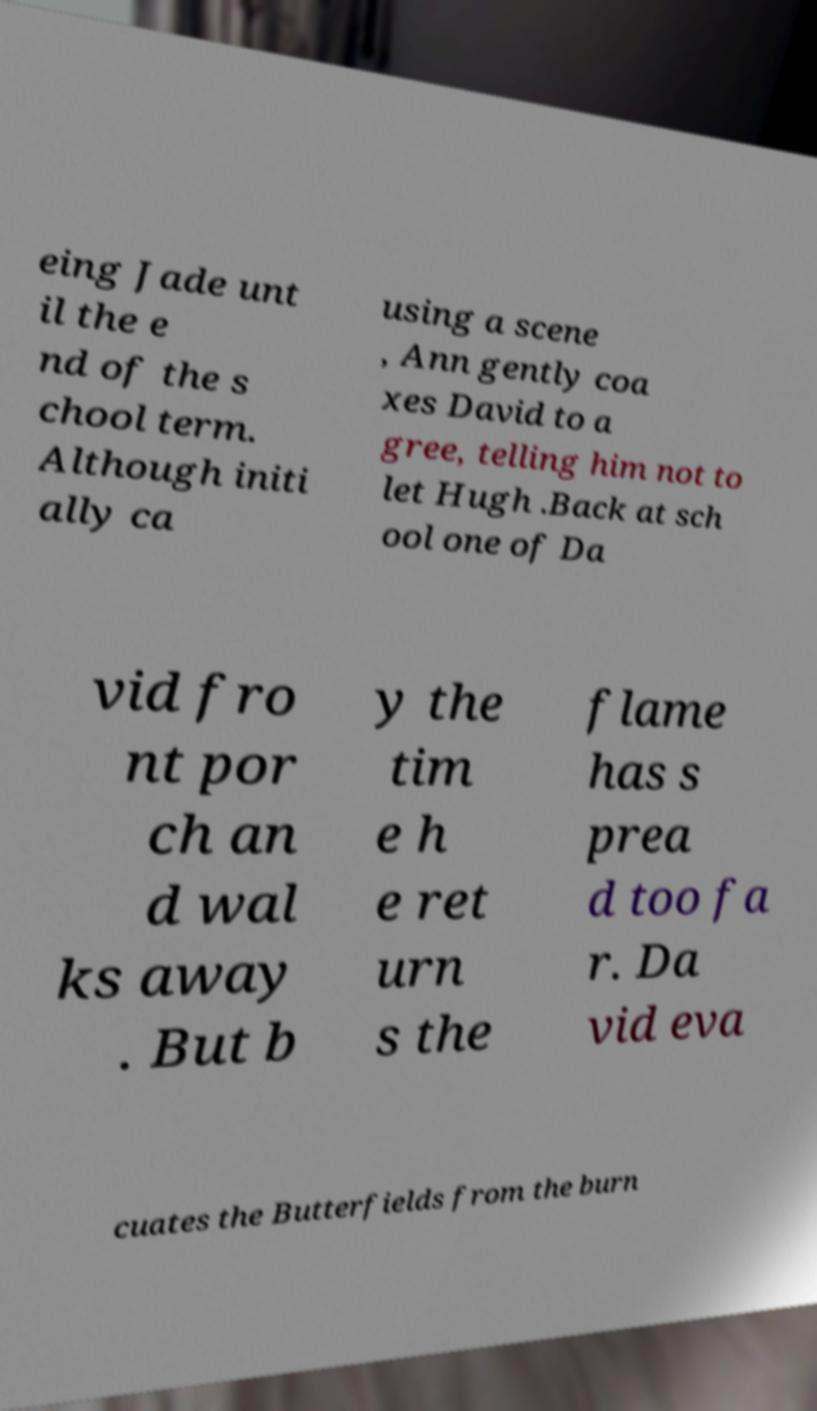Could you extract and type out the text from this image? eing Jade unt il the e nd of the s chool term. Although initi ally ca using a scene , Ann gently coa xes David to a gree, telling him not to let Hugh .Back at sch ool one of Da vid fro nt por ch an d wal ks away . But b y the tim e h e ret urn s the flame has s prea d too fa r. Da vid eva cuates the Butterfields from the burn 